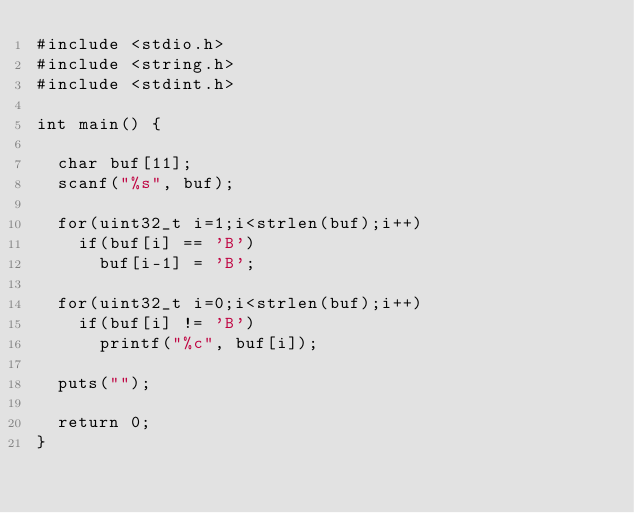Convert code to text. <code><loc_0><loc_0><loc_500><loc_500><_C_>#include <stdio.h>
#include <string.h>
#include <stdint.h>

int main() {

  char buf[11];
  scanf("%s", buf);

  for(uint32_t i=1;i<strlen(buf);i++)
    if(buf[i] == 'B')
      buf[i-1] = 'B';

  for(uint32_t i=0;i<strlen(buf);i++)
    if(buf[i] != 'B')
      printf("%c", buf[i]);

  puts("");

  return 0;
}
</code> 